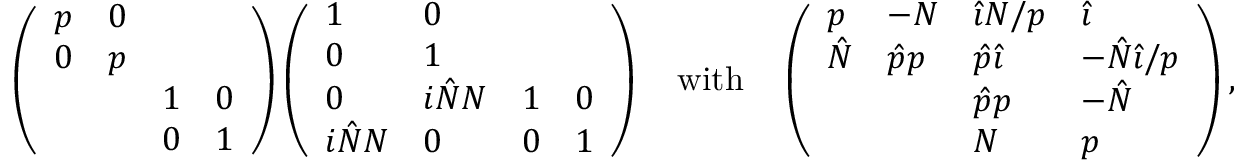Convert formula to latex. <formula><loc_0><loc_0><loc_500><loc_500>\left ( \begin{array} { l l l l } { p } & { 0 } & & \\ { 0 } & { p } & & \\ & & { 1 } & { 0 } \\ & & { 0 } & { 1 } \end{array} \right ) \left ( \begin{array} { l l l l } { 1 } & { 0 } & & \\ { 0 } & { 1 } & & \\ { 0 } & { i \hat { N } N } & { 1 } & { 0 } \\ { i \hat { N } N } & { 0 } & { 0 } & { 1 } \end{array} \right ) \quad w i t h \quad \left ( \begin{array} { l l l l } { p } & { - N } & { { \hat { \imath } } N / p } & { { \hat { \imath } } } \\ { \hat { N } } & { \hat { p } p } & { \hat { p } { \hat { \imath } } } & { - \hat { N } { \hat { \imath } } / p } \\ & & { \hat { p } p } & { - \hat { N } } \\ & & { N } & { p } \end{array} \right ) ,</formula> 